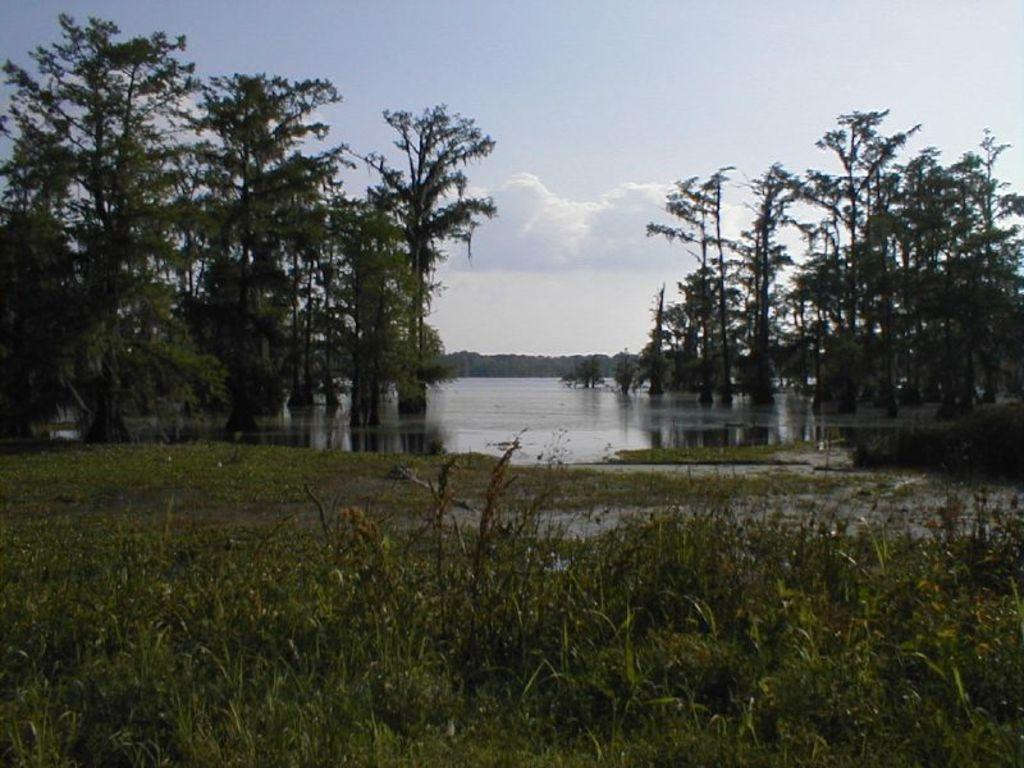What type of vegetation is present in the image? There is grass in the image. What else can be seen in the image besides grass? There is water and trees in the image. How are the trees distributed in the image? There are trees on the left side, right side, and in the background of the image. What is visible at the top of the image? The sky is clear and visible at the top of the image. Where is the needle used for sewing in the image? There is no needle present in the image. What type of form is being filled out by the trees in the image? There are no forms or tree-related activities depicted in the image. 